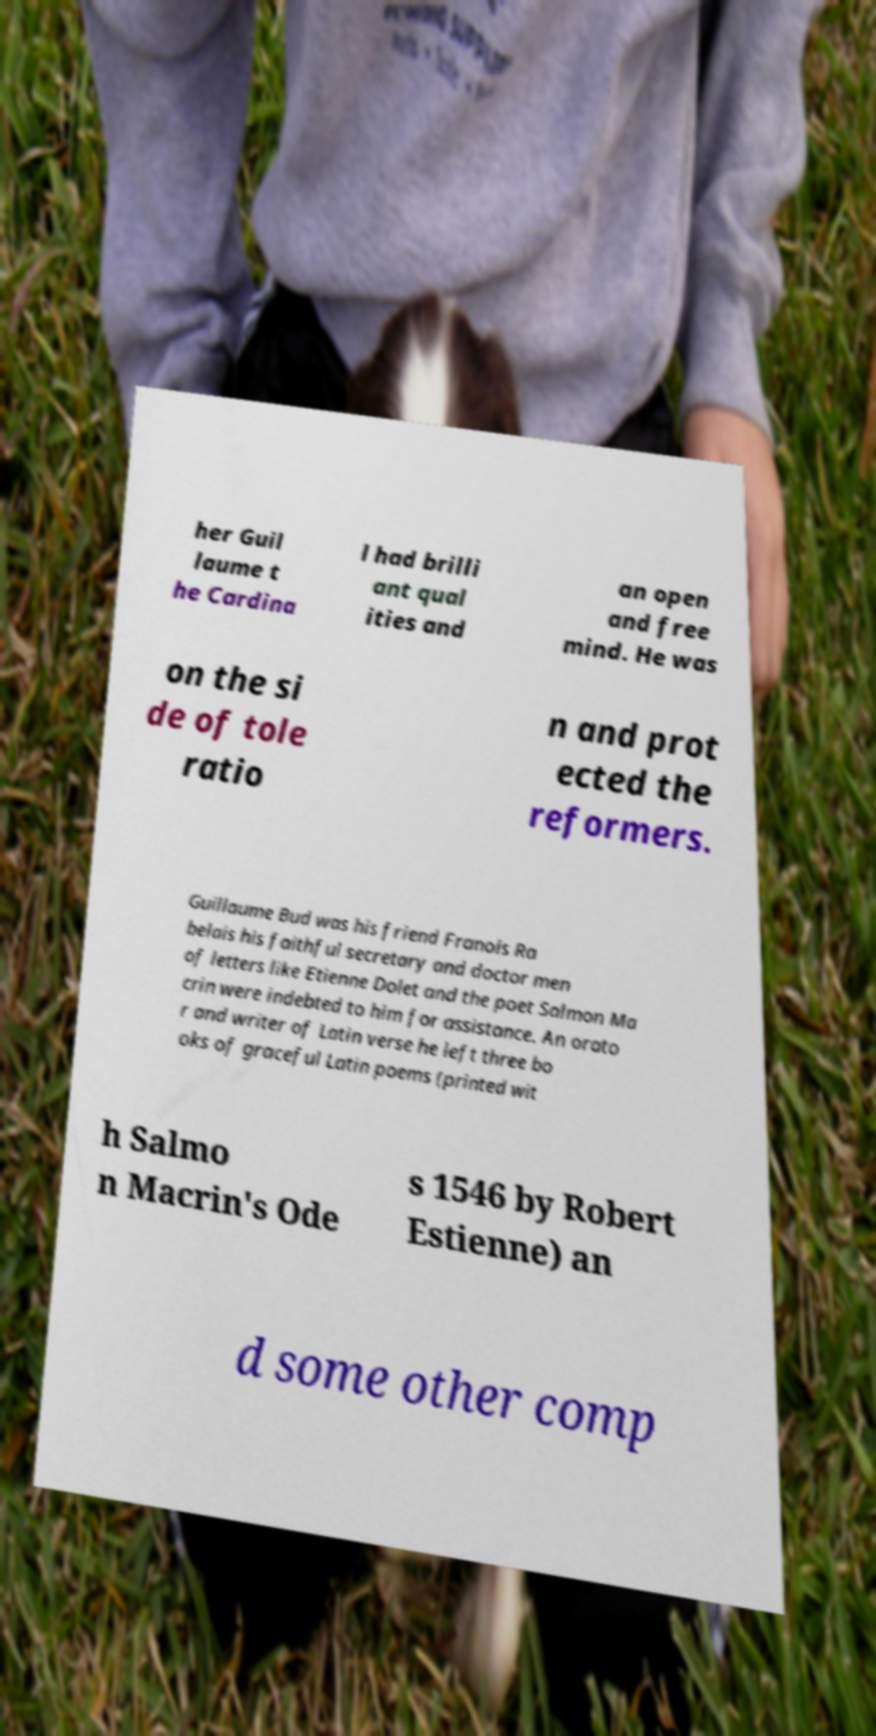Could you assist in decoding the text presented in this image and type it out clearly? her Guil laume t he Cardina l had brilli ant qual ities and an open and free mind. He was on the si de of tole ratio n and prot ected the reformers. Guillaume Bud was his friend Franois Ra belais his faithful secretary and doctor men of letters like Etienne Dolet and the poet Salmon Ma crin were indebted to him for assistance. An orato r and writer of Latin verse he left three bo oks of graceful Latin poems (printed wit h Salmo n Macrin's Ode s 1546 by Robert Estienne) an d some other comp 